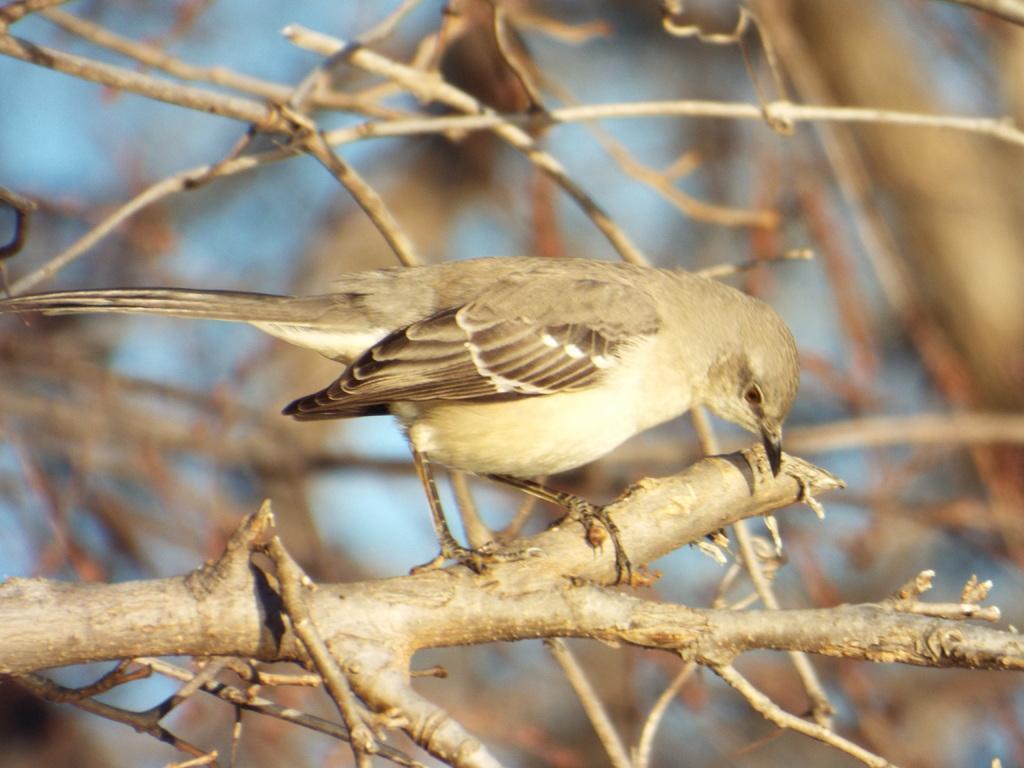In one or two sentences, can you explain what this image depicts? In this picture I can see there is a sparrow sitting on the trunk and there are twigs in the backdrop. 